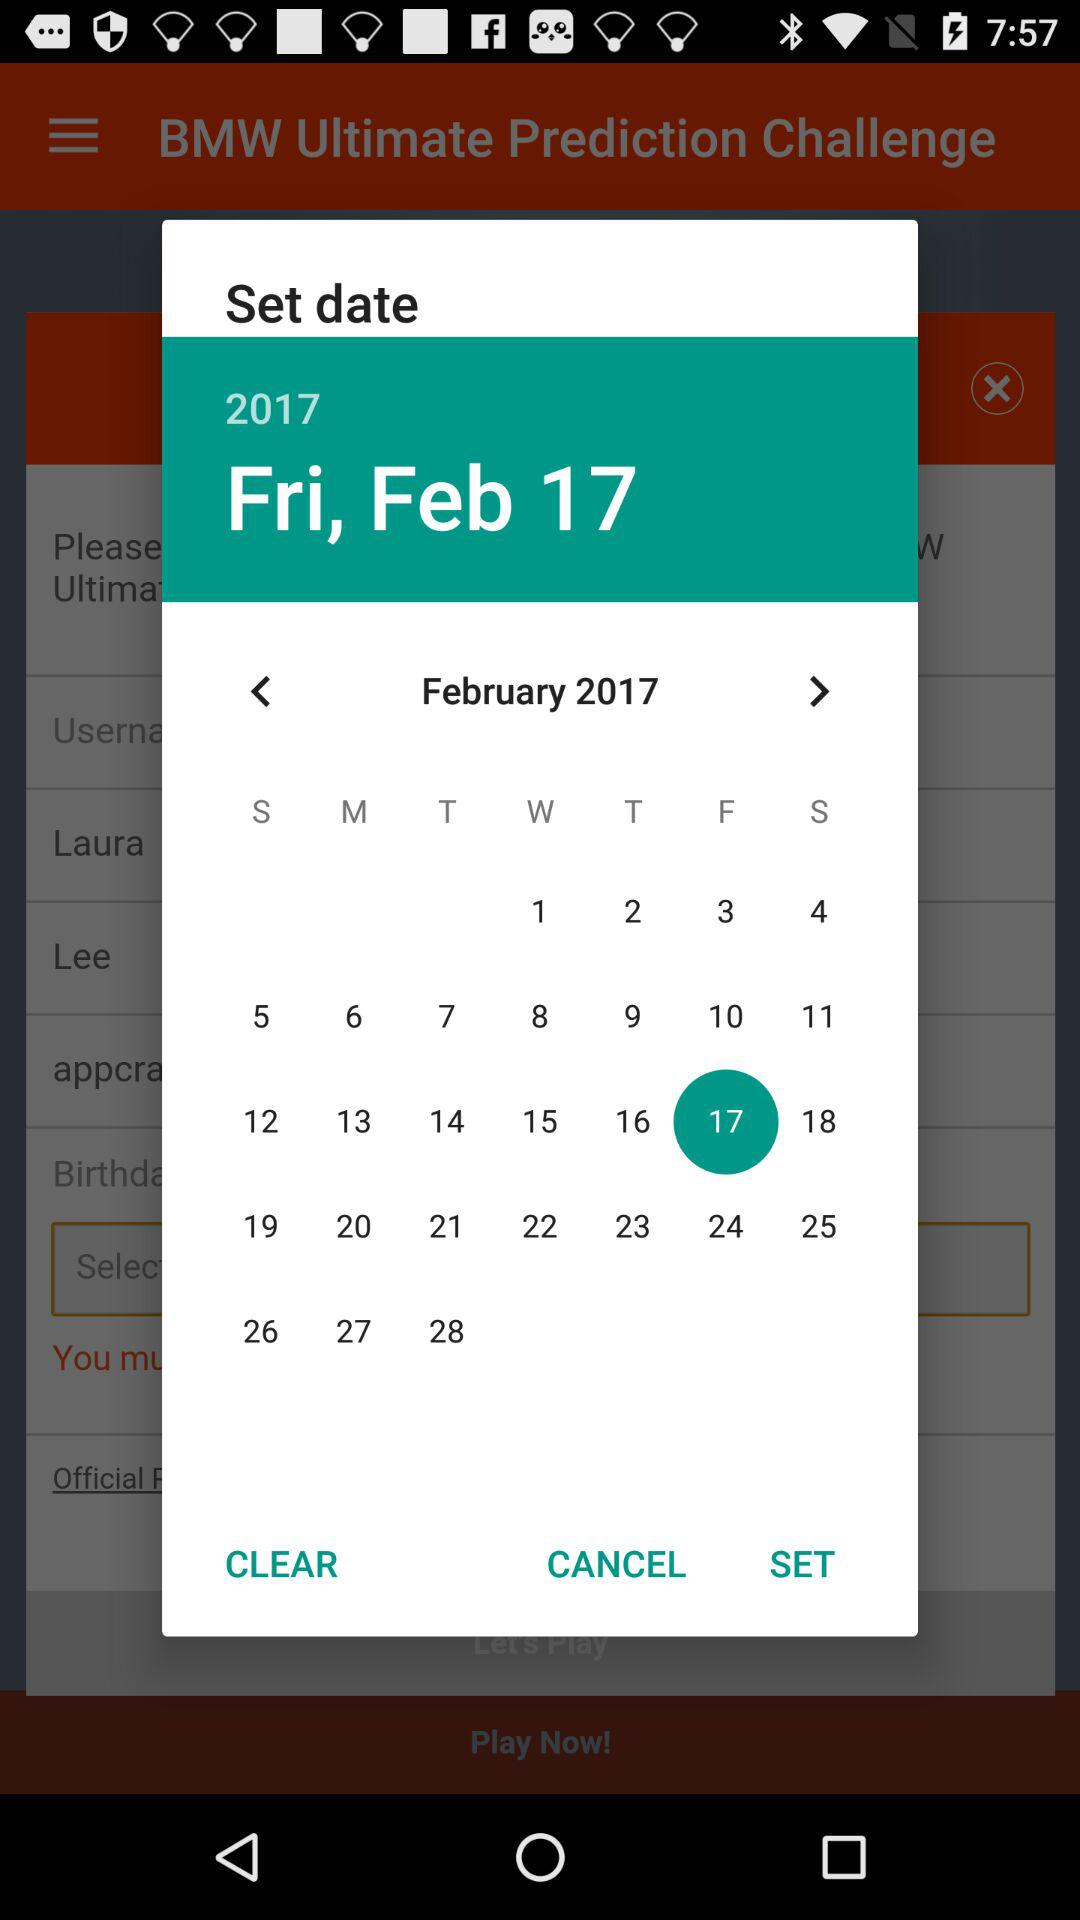How many days apart are the dates 2017-02-17 and 2017-02-28?
Answer the question using a single word or phrase. 11 